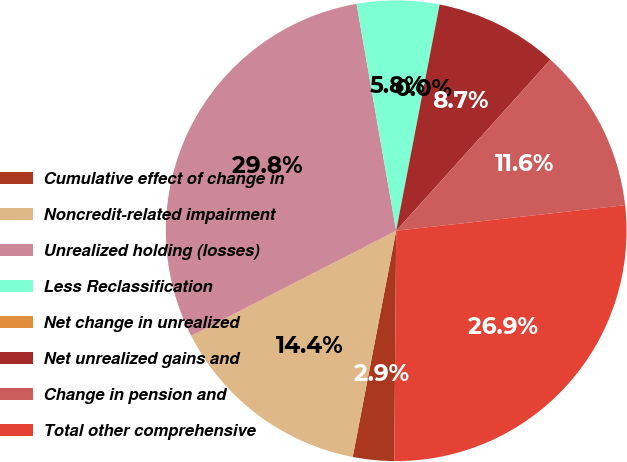Convert chart. <chart><loc_0><loc_0><loc_500><loc_500><pie_chart><fcel>Cumulative effect of change in<fcel>Noncredit-related impairment<fcel>Unrealized holding (losses)<fcel>Less Reclassification<fcel>Net change in unrealized<fcel>Net unrealized gains and<fcel>Change in pension and<fcel>Total other comprehensive<nl><fcel>2.89%<fcel>14.43%<fcel>29.79%<fcel>5.77%<fcel>0.0%<fcel>8.66%<fcel>11.55%<fcel>26.9%<nl></chart> 